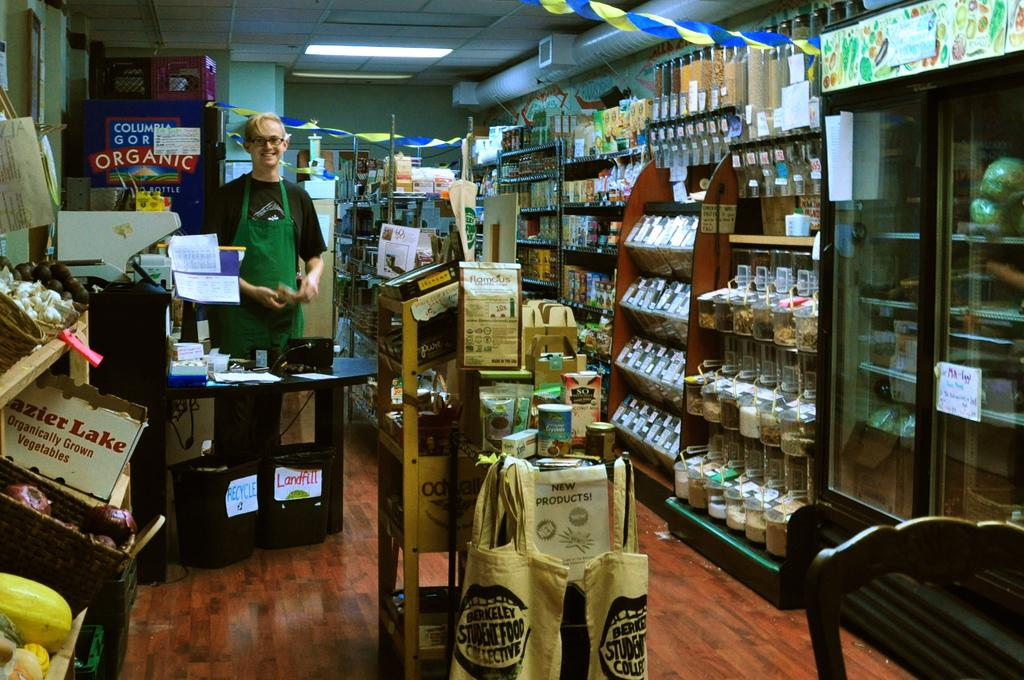<image>
Relay a brief, clear account of the picture shown. Inside a small shop with an employee in a green aprons smiling by the register and a sign that says Oranginc beside his head. 